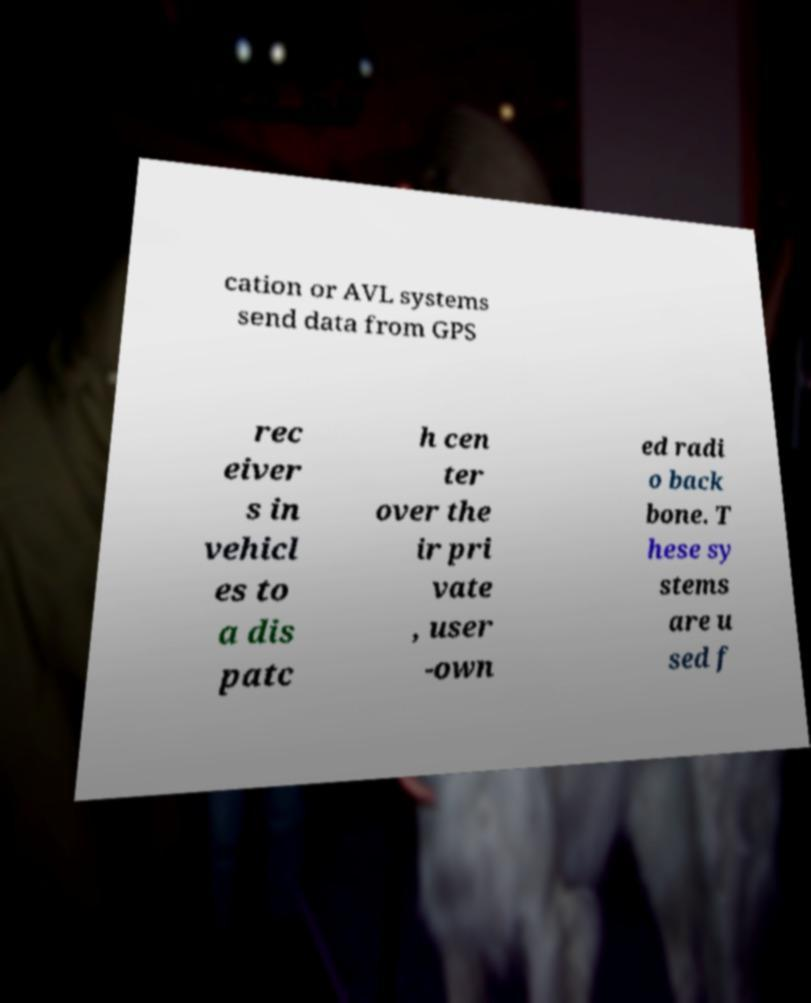Can you read and provide the text displayed in the image?This photo seems to have some interesting text. Can you extract and type it out for me? cation or AVL systems send data from GPS rec eiver s in vehicl es to a dis patc h cen ter over the ir pri vate , user -own ed radi o back bone. T hese sy stems are u sed f 